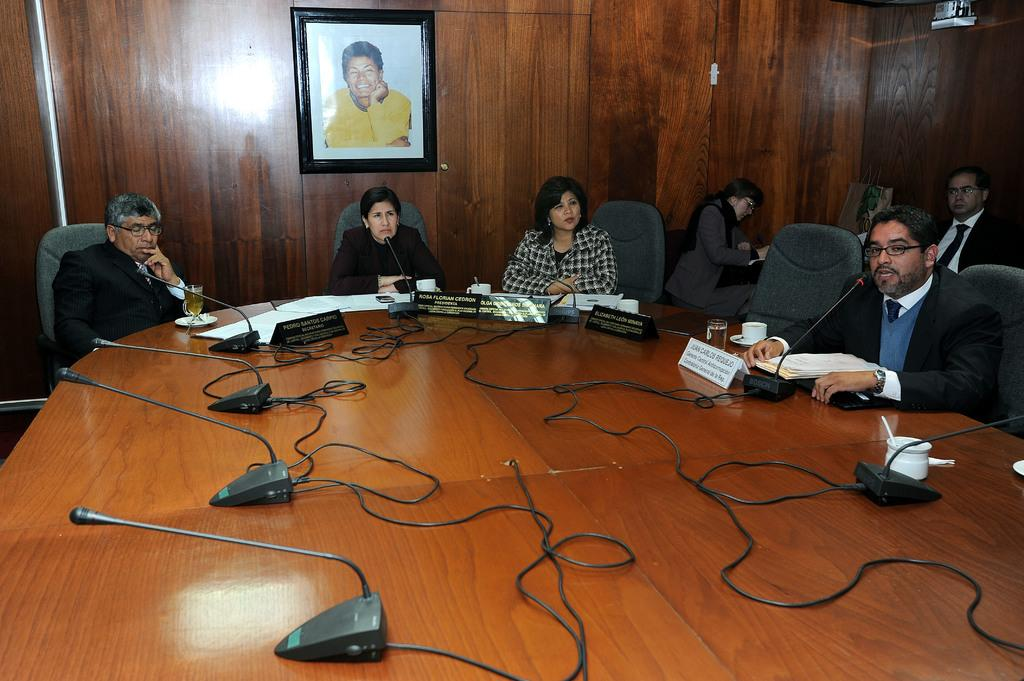What type of table is in the image? There is a wooden table in the image. What objects can be seen on the table? Microphones, a glass, cups, name plates, and papers are visible on the table. What might the people sitting on chairs be doing? The presence of microphones, name plates, and papers suggests that they might be participating in a meeting or discussion. Is there any decorative item in the image? Yes, there is a photo frame at the back of the scene. What type of plantation can be seen in the image? There is no plantation present in the image. What is the desire of the people sitting on chairs in the image? We cannot determine the desires of the people sitting on chairs from the image alone. 